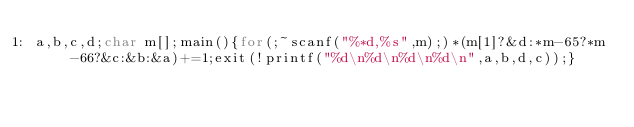Convert code to text. <code><loc_0><loc_0><loc_500><loc_500><_C_>a,b,c,d;char m[];main(){for(;~scanf("%*d,%s",m);)*(m[1]?&d:*m-65?*m-66?&c:&b:&a)+=1;exit(!printf("%d\n%d\n%d\n%d\n",a,b,d,c));}</code> 